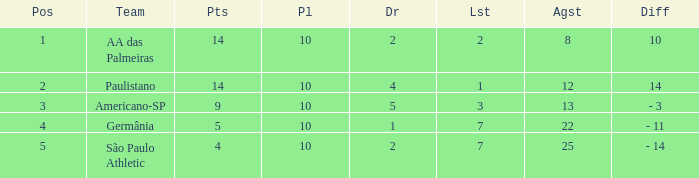What is the lowest Against when the played is more than 10? None. 